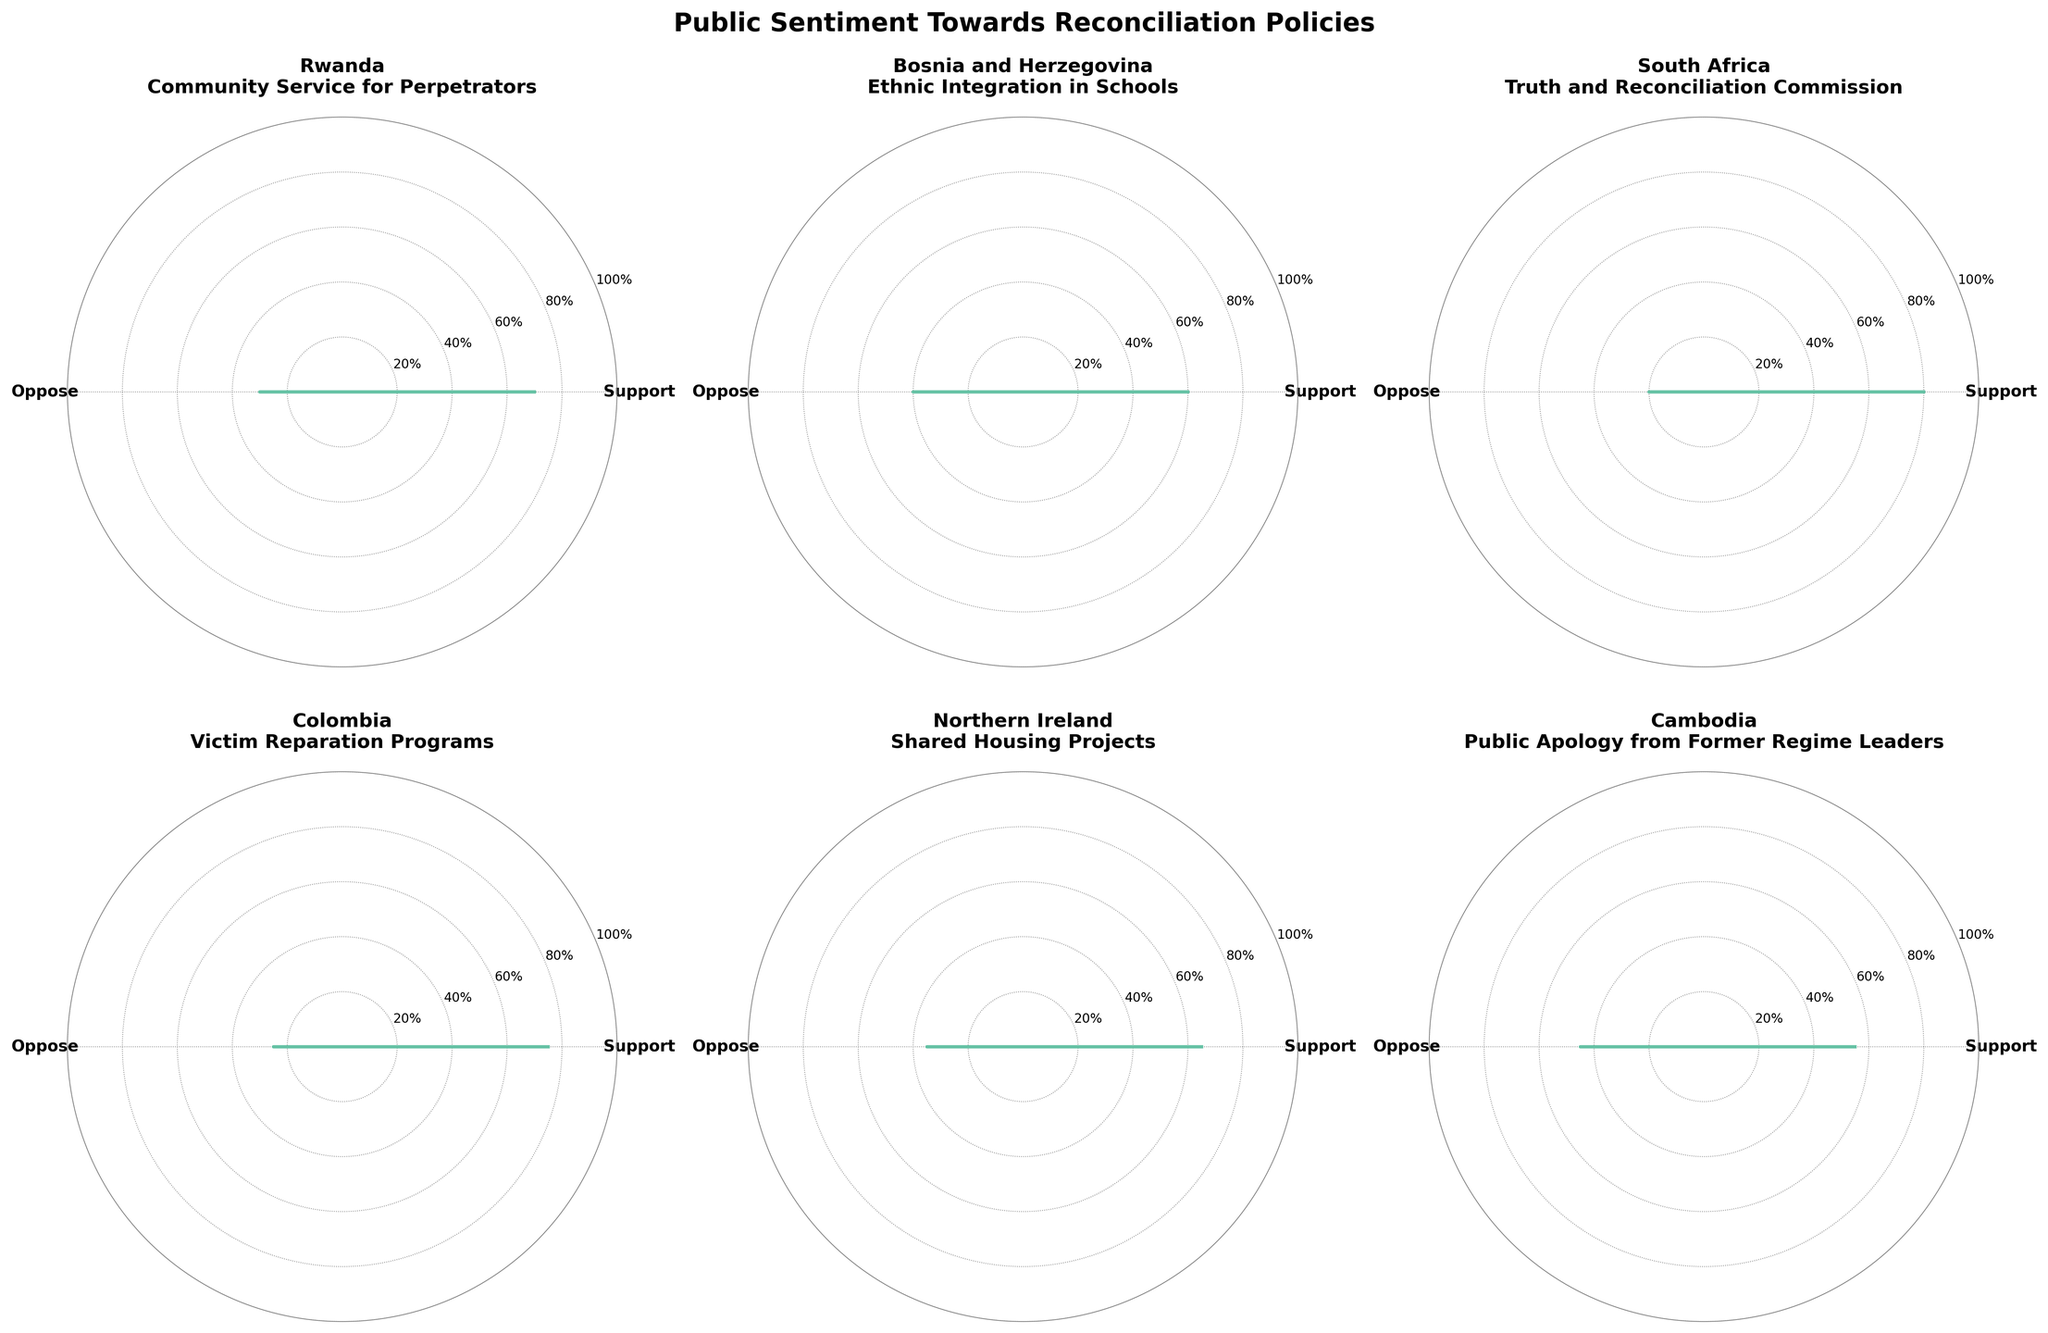Which country has the highest support for their reconciliation policy? From the figure, South Africa's policy receives 0.8 or 80% support, which is the highest compared to other countries' policies.
Answer: South Africa Which country's policy faces the most opposition? The figure shows that Cambodia's policy has the highest opposition at 0.45 or 45%, making it the most opposed policy among the presented countries.
Answer: Cambodia What is the difference in support between Rwanda's and Northern Ireland's policies? Rwanda's policy has 0.7 support, and Northern Ireland's policy has 0.65 support. The difference is calculated as 0.7 - 0.65 = 0.05 or 5%.
Answer: 0.05 Which policy is supported by the majority in all featured countries? Analyzing each subplot, all displayed policies have support proportions greater than opposition proportions, indicating majority support.
Answer: All How much more support does Colombia's policy receive compared to Bosnia and Herzegovina's policy? Colombia's policy receives 0.75 support, while Bosnia and Herzegovina's policy receives 0.6 support. The additional support is 0.75 - 0.6 = 0.15 or 15%.
Answer: 0.15 Which policy has the smallest gap between support and opposition? In the figure, Cambodia's policy has 0.55 support and 0.45 opposition, making the gap 0.55 - 0.45 = 0.1 or 10%, the smallest among all policies.
Answer: Cambodia What percentage of respondents support South Africa's Truth and Reconciliation Commission? The figure indicates that 0.8 or 80% of respondents support South Africa's Truth and Reconciliation Commission.
Answer: 80% Rank the countries from highest to lowest support for their reconciliation policies. From the figure: South Africa (0.8), Colombia (0.75), Rwanda (0.7), Northern Ireland (0.65), Bosnia and Herzegovina (0.6), Cambodia (0.55).
Answer: South Africa, Colombia, Rwanda, Northern Ireland, Bosnia and Herzegovina, Cambodia Does any country have an equal proportion of support and opposition for their policy? The polar charts show that no country's policy has equal support and opposition percentages; support always outweighs opposition.
Answer: No 